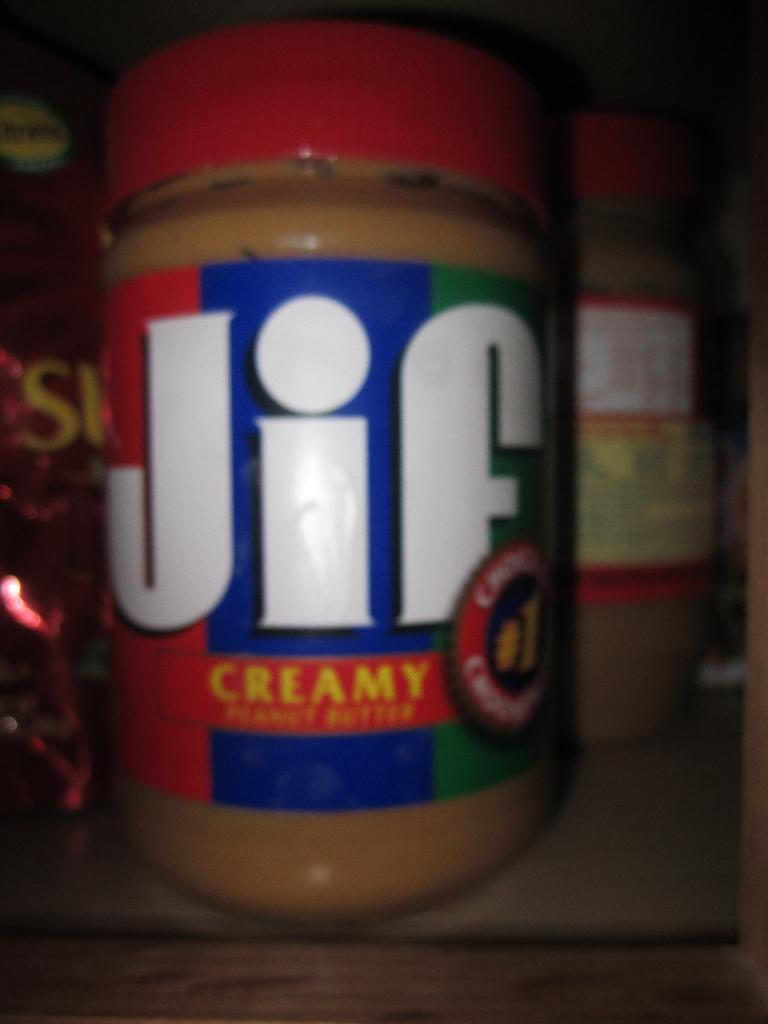What is present in the image? There is a bottle in the image. What can be identified from the label on the bottle? The bottle is labeled as "jif". Where is the bottle located in the image? The bottle is placed on a table. What type of prose is written on the bottle in the image? There is no prose written on the bottle in the image; it is labeled as "jif". Can you tell me how many forks are visible in the image? There is no fork present in the image; it only features a bottle labeled as "jif" on a table. 